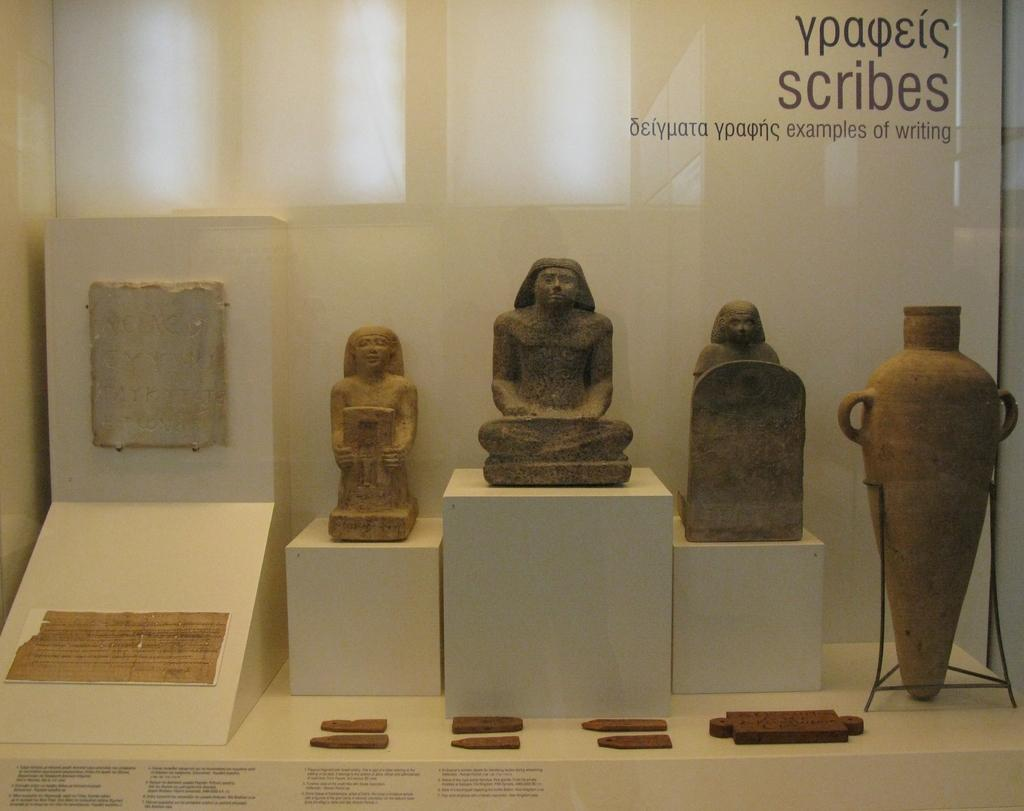What type of structures are visible in the image? There are stone structures in the image. How are the stone structures contained in the image? The stone structures are placed in a glass container. What else can be seen on the surface in the image? There are places (possibly game pieces) on a box in the image. Where is the text located in the image? The text is in the top right corner of the image. What is the distance between the stone structures and the police in the image? There are no police present in the image, so it is not possible to determine the distance between the stone structures and the police. 